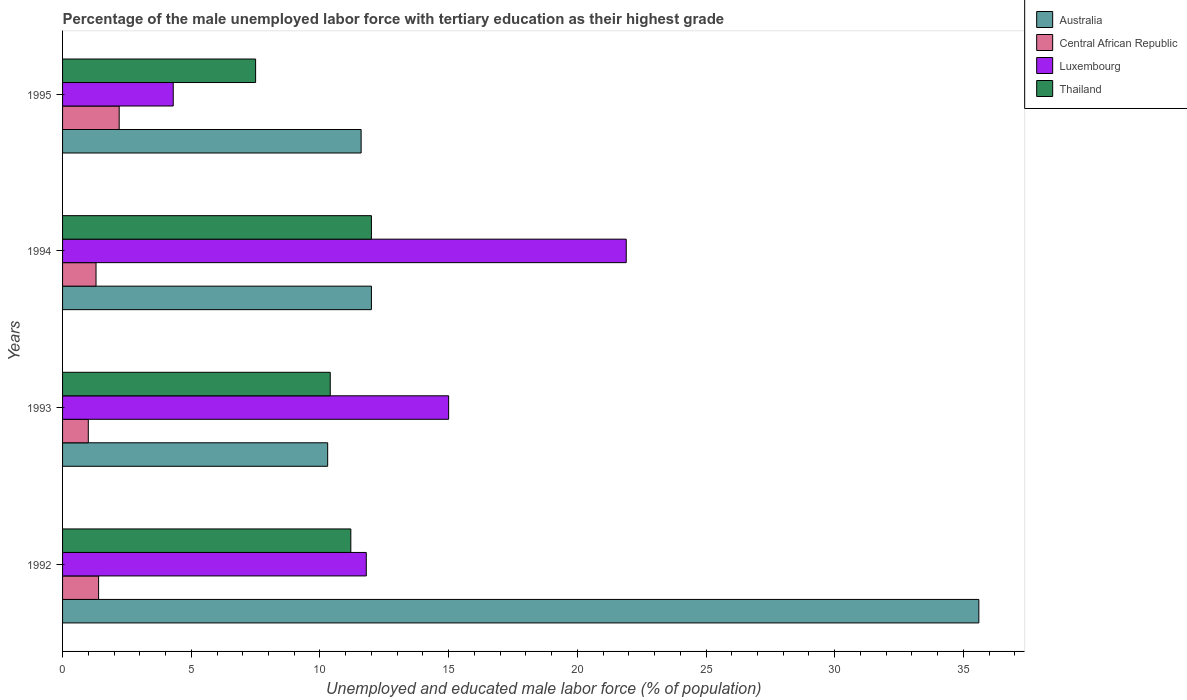How many groups of bars are there?
Provide a short and direct response. 4. Are the number of bars per tick equal to the number of legend labels?
Your answer should be compact. Yes. How many bars are there on the 2nd tick from the bottom?
Offer a terse response. 4. What is the percentage of the unemployed male labor force with tertiary education in Australia in 1993?
Your answer should be very brief. 10.3. Across all years, what is the maximum percentage of the unemployed male labor force with tertiary education in Central African Republic?
Your answer should be compact. 2.2. Across all years, what is the minimum percentage of the unemployed male labor force with tertiary education in Luxembourg?
Provide a short and direct response. 4.3. What is the total percentage of the unemployed male labor force with tertiary education in Australia in the graph?
Your answer should be compact. 69.5. What is the difference between the percentage of the unemployed male labor force with tertiary education in Central African Republic in 1992 and that in 1995?
Keep it short and to the point. -0.8. What is the difference between the percentage of the unemployed male labor force with tertiary education in Central African Republic in 1992 and the percentage of the unemployed male labor force with tertiary education in Luxembourg in 1995?
Your answer should be very brief. -2.9. What is the average percentage of the unemployed male labor force with tertiary education in Thailand per year?
Ensure brevity in your answer.  10.27. In the year 1992, what is the difference between the percentage of the unemployed male labor force with tertiary education in Australia and percentage of the unemployed male labor force with tertiary education in Thailand?
Your response must be concise. 24.4. What is the ratio of the percentage of the unemployed male labor force with tertiary education in Thailand in 1992 to that in 1994?
Make the answer very short. 0.93. Is the percentage of the unemployed male labor force with tertiary education in Australia in 1994 less than that in 1995?
Provide a succinct answer. No. Is the difference between the percentage of the unemployed male labor force with tertiary education in Australia in 1992 and 1995 greater than the difference between the percentage of the unemployed male labor force with tertiary education in Thailand in 1992 and 1995?
Your response must be concise. Yes. What is the difference between the highest and the second highest percentage of the unemployed male labor force with tertiary education in Luxembourg?
Keep it short and to the point. 6.9. In how many years, is the percentage of the unemployed male labor force with tertiary education in Thailand greater than the average percentage of the unemployed male labor force with tertiary education in Thailand taken over all years?
Provide a succinct answer. 3. Is the sum of the percentage of the unemployed male labor force with tertiary education in Thailand in 1992 and 1993 greater than the maximum percentage of the unemployed male labor force with tertiary education in Central African Republic across all years?
Offer a terse response. Yes. What does the 3rd bar from the top in 1992 represents?
Your response must be concise. Central African Republic. What does the 3rd bar from the bottom in 1993 represents?
Ensure brevity in your answer.  Luxembourg. Are the values on the major ticks of X-axis written in scientific E-notation?
Provide a short and direct response. No. Does the graph contain grids?
Offer a very short reply. No. Where does the legend appear in the graph?
Ensure brevity in your answer.  Top right. How many legend labels are there?
Offer a terse response. 4. What is the title of the graph?
Provide a succinct answer. Percentage of the male unemployed labor force with tertiary education as their highest grade. What is the label or title of the X-axis?
Your response must be concise. Unemployed and educated male labor force (% of population). What is the Unemployed and educated male labor force (% of population) in Australia in 1992?
Offer a very short reply. 35.6. What is the Unemployed and educated male labor force (% of population) of Central African Republic in 1992?
Your answer should be very brief. 1.4. What is the Unemployed and educated male labor force (% of population) of Luxembourg in 1992?
Make the answer very short. 11.8. What is the Unemployed and educated male labor force (% of population) in Thailand in 1992?
Offer a terse response. 11.2. What is the Unemployed and educated male labor force (% of population) of Australia in 1993?
Provide a succinct answer. 10.3. What is the Unemployed and educated male labor force (% of population) of Thailand in 1993?
Provide a short and direct response. 10.4. What is the Unemployed and educated male labor force (% of population) in Central African Republic in 1994?
Keep it short and to the point. 1.3. What is the Unemployed and educated male labor force (% of population) of Luxembourg in 1994?
Give a very brief answer. 21.9. What is the Unemployed and educated male labor force (% of population) in Thailand in 1994?
Provide a succinct answer. 12. What is the Unemployed and educated male labor force (% of population) of Australia in 1995?
Make the answer very short. 11.6. What is the Unemployed and educated male labor force (% of population) in Central African Republic in 1995?
Make the answer very short. 2.2. What is the Unemployed and educated male labor force (% of population) in Luxembourg in 1995?
Offer a terse response. 4.3. What is the Unemployed and educated male labor force (% of population) in Thailand in 1995?
Make the answer very short. 7.5. Across all years, what is the maximum Unemployed and educated male labor force (% of population) of Australia?
Provide a short and direct response. 35.6. Across all years, what is the maximum Unemployed and educated male labor force (% of population) of Central African Republic?
Ensure brevity in your answer.  2.2. Across all years, what is the maximum Unemployed and educated male labor force (% of population) of Luxembourg?
Ensure brevity in your answer.  21.9. Across all years, what is the minimum Unemployed and educated male labor force (% of population) of Australia?
Offer a terse response. 10.3. Across all years, what is the minimum Unemployed and educated male labor force (% of population) of Luxembourg?
Give a very brief answer. 4.3. What is the total Unemployed and educated male labor force (% of population) of Australia in the graph?
Give a very brief answer. 69.5. What is the total Unemployed and educated male labor force (% of population) in Central African Republic in the graph?
Offer a terse response. 5.9. What is the total Unemployed and educated male labor force (% of population) of Luxembourg in the graph?
Give a very brief answer. 53. What is the total Unemployed and educated male labor force (% of population) in Thailand in the graph?
Keep it short and to the point. 41.1. What is the difference between the Unemployed and educated male labor force (% of population) in Australia in 1992 and that in 1993?
Keep it short and to the point. 25.3. What is the difference between the Unemployed and educated male labor force (% of population) of Luxembourg in 1992 and that in 1993?
Offer a terse response. -3.2. What is the difference between the Unemployed and educated male labor force (% of population) of Thailand in 1992 and that in 1993?
Make the answer very short. 0.8. What is the difference between the Unemployed and educated male labor force (% of population) of Australia in 1992 and that in 1994?
Provide a succinct answer. 23.6. What is the difference between the Unemployed and educated male labor force (% of population) in Thailand in 1992 and that in 1994?
Give a very brief answer. -0.8. What is the difference between the Unemployed and educated male labor force (% of population) in Australia in 1992 and that in 1995?
Offer a terse response. 24. What is the difference between the Unemployed and educated male labor force (% of population) in Luxembourg in 1992 and that in 1995?
Your response must be concise. 7.5. What is the difference between the Unemployed and educated male labor force (% of population) of Thailand in 1992 and that in 1995?
Keep it short and to the point. 3.7. What is the difference between the Unemployed and educated male labor force (% of population) in Australia in 1993 and that in 1994?
Make the answer very short. -1.7. What is the difference between the Unemployed and educated male labor force (% of population) of Central African Republic in 1993 and that in 1994?
Give a very brief answer. -0.3. What is the difference between the Unemployed and educated male labor force (% of population) in Luxembourg in 1993 and that in 1994?
Your answer should be very brief. -6.9. What is the difference between the Unemployed and educated male labor force (% of population) in Thailand in 1993 and that in 1994?
Make the answer very short. -1.6. What is the difference between the Unemployed and educated male labor force (% of population) of Central African Republic in 1993 and that in 1995?
Your response must be concise. -1.2. What is the difference between the Unemployed and educated male labor force (% of population) in Central African Republic in 1994 and that in 1995?
Give a very brief answer. -0.9. What is the difference between the Unemployed and educated male labor force (% of population) of Luxembourg in 1994 and that in 1995?
Offer a very short reply. 17.6. What is the difference between the Unemployed and educated male labor force (% of population) in Australia in 1992 and the Unemployed and educated male labor force (% of population) in Central African Republic in 1993?
Make the answer very short. 34.6. What is the difference between the Unemployed and educated male labor force (% of population) of Australia in 1992 and the Unemployed and educated male labor force (% of population) of Luxembourg in 1993?
Keep it short and to the point. 20.6. What is the difference between the Unemployed and educated male labor force (% of population) of Australia in 1992 and the Unemployed and educated male labor force (% of population) of Thailand in 1993?
Ensure brevity in your answer.  25.2. What is the difference between the Unemployed and educated male labor force (% of population) of Central African Republic in 1992 and the Unemployed and educated male labor force (% of population) of Luxembourg in 1993?
Give a very brief answer. -13.6. What is the difference between the Unemployed and educated male labor force (% of population) of Central African Republic in 1992 and the Unemployed and educated male labor force (% of population) of Thailand in 1993?
Provide a short and direct response. -9. What is the difference between the Unemployed and educated male labor force (% of population) of Australia in 1992 and the Unemployed and educated male labor force (% of population) of Central African Republic in 1994?
Provide a short and direct response. 34.3. What is the difference between the Unemployed and educated male labor force (% of population) in Australia in 1992 and the Unemployed and educated male labor force (% of population) in Thailand in 1994?
Offer a very short reply. 23.6. What is the difference between the Unemployed and educated male labor force (% of population) in Central African Republic in 1992 and the Unemployed and educated male labor force (% of population) in Luxembourg in 1994?
Ensure brevity in your answer.  -20.5. What is the difference between the Unemployed and educated male labor force (% of population) in Luxembourg in 1992 and the Unemployed and educated male labor force (% of population) in Thailand in 1994?
Keep it short and to the point. -0.2. What is the difference between the Unemployed and educated male labor force (% of population) of Australia in 1992 and the Unemployed and educated male labor force (% of population) of Central African Republic in 1995?
Make the answer very short. 33.4. What is the difference between the Unemployed and educated male labor force (% of population) of Australia in 1992 and the Unemployed and educated male labor force (% of population) of Luxembourg in 1995?
Ensure brevity in your answer.  31.3. What is the difference between the Unemployed and educated male labor force (% of population) in Australia in 1992 and the Unemployed and educated male labor force (% of population) in Thailand in 1995?
Your answer should be compact. 28.1. What is the difference between the Unemployed and educated male labor force (% of population) in Central African Republic in 1992 and the Unemployed and educated male labor force (% of population) in Luxembourg in 1995?
Ensure brevity in your answer.  -2.9. What is the difference between the Unemployed and educated male labor force (% of population) in Central African Republic in 1992 and the Unemployed and educated male labor force (% of population) in Thailand in 1995?
Ensure brevity in your answer.  -6.1. What is the difference between the Unemployed and educated male labor force (% of population) of Luxembourg in 1992 and the Unemployed and educated male labor force (% of population) of Thailand in 1995?
Offer a very short reply. 4.3. What is the difference between the Unemployed and educated male labor force (% of population) of Australia in 1993 and the Unemployed and educated male labor force (% of population) of Luxembourg in 1994?
Your answer should be compact. -11.6. What is the difference between the Unemployed and educated male labor force (% of population) in Australia in 1993 and the Unemployed and educated male labor force (% of population) in Thailand in 1994?
Provide a succinct answer. -1.7. What is the difference between the Unemployed and educated male labor force (% of population) in Central African Republic in 1993 and the Unemployed and educated male labor force (% of population) in Luxembourg in 1994?
Provide a short and direct response. -20.9. What is the difference between the Unemployed and educated male labor force (% of population) in Central African Republic in 1993 and the Unemployed and educated male labor force (% of population) in Thailand in 1994?
Offer a very short reply. -11. What is the difference between the Unemployed and educated male labor force (% of population) of Luxembourg in 1993 and the Unemployed and educated male labor force (% of population) of Thailand in 1994?
Offer a terse response. 3. What is the difference between the Unemployed and educated male labor force (% of population) of Australia in 1993 and the Unemployed and educated male labor force (% of population) of Central African Republic in 1995?
Give a very brief answer. 8.1. What is the difference between the Unemployed and educated male labor force (% of population) in Australia in 1993 and the Unemployed and educated male labor force (% of population) in Luxembourg in 1995?
Provide a short and direct response. 6. What is the difference between the Unemployed and educated male labor force (% of population) in Central African Republic in 1993 and the Unemployed and educated male labor force (% of population) in Thailand in 1995?
Your answer should be compact. -6.5. What is the difference between the Unemployed and educated male labor force (% of population) of Central African Republic in 1994 and the Unemployed and educated male labor force (% of population) of Thailand in 1995?
Give a very brief answer. -6.2. What is the difference between the Unemployed and educated male labor force (% of population) in Luxembourg in 1994 and the Unemployed and educated male labor force (% of population) in Thailand in 1995?
Keep it short and to the point. 14.4. What is the average Unemployed and educated male labor force (% of population) of Australia per year?
Ensure brevity in your answer.  17.38. What is the average Unemployed and educated male labor force (% of population) in Central African Republic per year?
Your answer should be compact. 1.48. What is the average Unemployed and educated male labor force (% of population) in Luxembourg per year?
Your answer should be very brief. 13.25. What is the average Unemployed and educated male labor force (% of population) of Thailand per year?
Offer a terse response. 10.28. In the year 1992, what is the difference between the Unemployed and educated male labor force (% of population) in Australia and Unemployed and educated male labor force (% of population) in Central African Republic?
Make the answer very short. 34.2. In the year 1992, what is the difference between the Unemployed and educated male labor force (% of population) in Australia and Unemployed and educated male labor force (% of population) in Luxembourg?
Your answer should be very brief. 23.8. In the year 1992, what is the difference between the Unemployed and educated male labor force (% of population) of Australia and Unemployed and educated male labor force (% of population) of Thailand?
Offer a terse response. 24.4. In the year 1992, what is the difference between the Unemployed and educated male labor force (% of population) in Central African Republic and Unemployed and educated male labor force (% of population) in Luxembourg?
Offer a terse response. -10.4. In the year 1992, what is the difference between the Unemployed and educated male labor force (% of population) of Central African Republic and Unemployed and educated male labor force (% of population) of Thailand?
Offer a very short reply. -9.8. In the year 1993, what is the difference between the Unemployed and educated male labor force (% of population) in Australia and Unemployed and educated male labor force (% of population) in Central African Republic?
Provide a succinct answer. 9.3. In the year 1993, what is the difference between the Unemployed and educated male labor force (% of population) of Central African Republic and Unemployed and educated male labor force (% of population) of Luxembourg?
Make the answer very short. -14. In the year 1994, what is the difference between the Unemployed and educated male labor force (% of population) in Australia and Unemployed and educated male labor force (% of population) in Central African Republic?
Offer a very short reply. 10.7. In the year 1994, what is the difference between the Unemployed and educated male labor force (% of population) of Australia and Unemployed and educated male labor force (% of population) of Luxembourg?
Your answer should be compact. -9.9. In the year 1994, what is the difference between the Unemployed and educated male labor force (% of population) of Central African Republic and Unemployed and educated male labor force (% of population) of Luxembourg?
Your answer should be very brief. -20.6. In the year 1994, what is the difference between the Unemployed and educated male labor force (% of population) of Central African Republic and Unemployed and educated male labor force (% of population) of Thailand?
Your response must be concise. -10.7. In the year 1995, what is the difference between the Unemployed and educated male labor force (% of population) in Australia and Unemployed and educated male labor force (% of population) in Luxembourg?
Give a very brief answer. 7.3. In the year 1995, what is the difference between the Unemployed and educated male labor force (% of population) of Central African Republic and Unemployed and educated male labor force (% of population) of Thailand?
Make the answer very short. -5.3. What is the ratio of the Unemployed and educated male labor force (% of population) in Australia in 1992 to that in 1993?
Provide a succinct answer. 3.46. What is the ratio of the Unemployed and educated male labor force (% of population) in Central African Republic in 1992 to that in 1993?
Your answer should be very brief. 1.4. What is the ratio of the Unemployed and educated male labor force (% of population) in Luxembourg in 1992 to that in 1993?
Give a very brief answer. 0.79. What is the ratio of the Unemployed and educated male labor force (% of population) in Australia in 1992 to that in 1994?
Your answer should be compact. 2.97. What is the ratio of the Unemployed and educated male labor force (% of population) of Luxembourg in 1992 to that in 1994?
Make the answer very short. 0.54. What is the ratio of the Unemployed and educated male labor force (% of population) in Australia in 1992 to that in 1995?
Your response must be concise. 3.07. What is the ratio of the Unemployed and educated male labor force (% of population) of Central African Republic in 1992 to that in 1995?
Offer a terse response. 0.64. What is the ratio of the Unemployed and educated male labor force (% of population) of Luxembourg in 1992 to that in 1995?
Offer a terse response. 2.74. What is the ratio of the Unemployed and educated male labor force (% of population) in Thailand in 1992 to that in 1995?
Your response must be concise. 1.49. What is the ratio of the Unemployed and educated male labor force (% of population) in Australia in 1993 to that in 1994?
Keep it short and to the point. 0.86. What is the ratio of the Unemployed and educated male labor force (% of population) of Central African Republic in 1993 to that in 1994?
Provide a succinct answer. 0.77. What is the ratio of the Unemployed and educated male labor force (% of population) of Luxembourg in 1993 to that in 1994?
Provide a short and direct response. 0.68. What is the ratio of the Unemployed and educated male labor force (% of population) in Thailand in 1993 to that in 1994?
Keep it short and to the point. 0.87. What is the ratio of the Unemployed and educated male labor force (% of population) of Australia in 1993 to that in 1995?
Make the answer very short. 0.89. What is the ratio of the Unemployed and educated male labor force (% of population) in Central African Republic in 1993 to that in 1995?
Keep it short and to the point. 0.45. What is the ratio of the Unemployed and educated male labor force (% of population) of Luxembourg in 1993 to that in 1995?
Provide a short and direct response. 3.49. What is the ratio of the Unemployed and educated male labor force (% of population) of Thailand in 1993 to that in 1995?
Offer a very short reply. 1.39. What is the ratio of the Unemployed and educated male labor force (% of population) of Australia in 1994 to that in 1995?
Provide a short and direct response. 1.03. What is the ratio of the Unemployed and educated male labor force (% of population) in Central African Republic in 1994 to that in 1995?
Give a very brief answer. 0.59. What is the ratio of the Unemployed and educated male labor force (% of population) in Luxembourg in 1994 to that in 1995?
Offer a terse response. 5.09. What is the ratio of the Unemployed and educated male labor force (% of population) of Thailand in 1994 to that in 1995?
Keep it short and to the point. 1.6. What is the difference between the highest and the second highest Unemployed and educated male labor force (% of population) in Australia?
Give a very brief answer. 23.6. What is the difference between the highest and the second highest Unemployed and educated male labor force (% of population) in Luxembourg?
Offer a terse response. 6.9. What is the difference between the highest and the second highest Unemployed and educated male labor force (% of population) in Thailand?
Offer a terse response. 0.8. What is the difference between the highest and the lowest Unemployed and educated male labor force (% of population) of Australia?
Provide a short and direct response. 25.3. What is the difference between the highest and the lowest Unemployed and educated male labor force (% of population) of Thailand?
Provide a short and direct response. 4.5. 